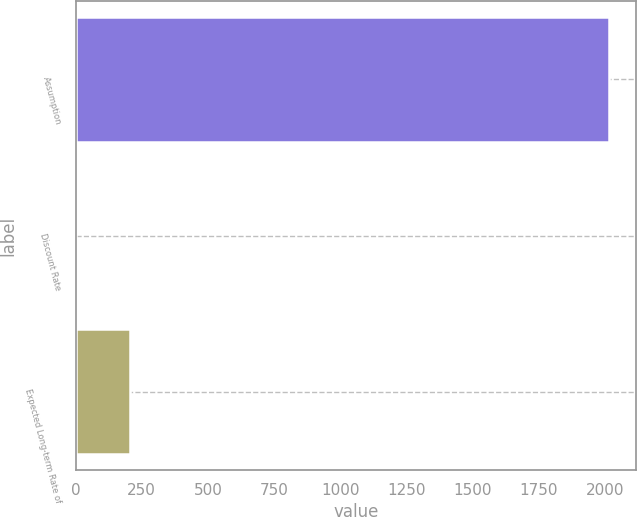<chart> <loc_0><loc_0><loc_500><loc_500><bar_chart><fcel>Assumption<fcel>Discount Rate<fcel>Expected Long-term Rate of<nl><fcel>2017<fcel>2.7<fcel>204.13<nl></chart> 